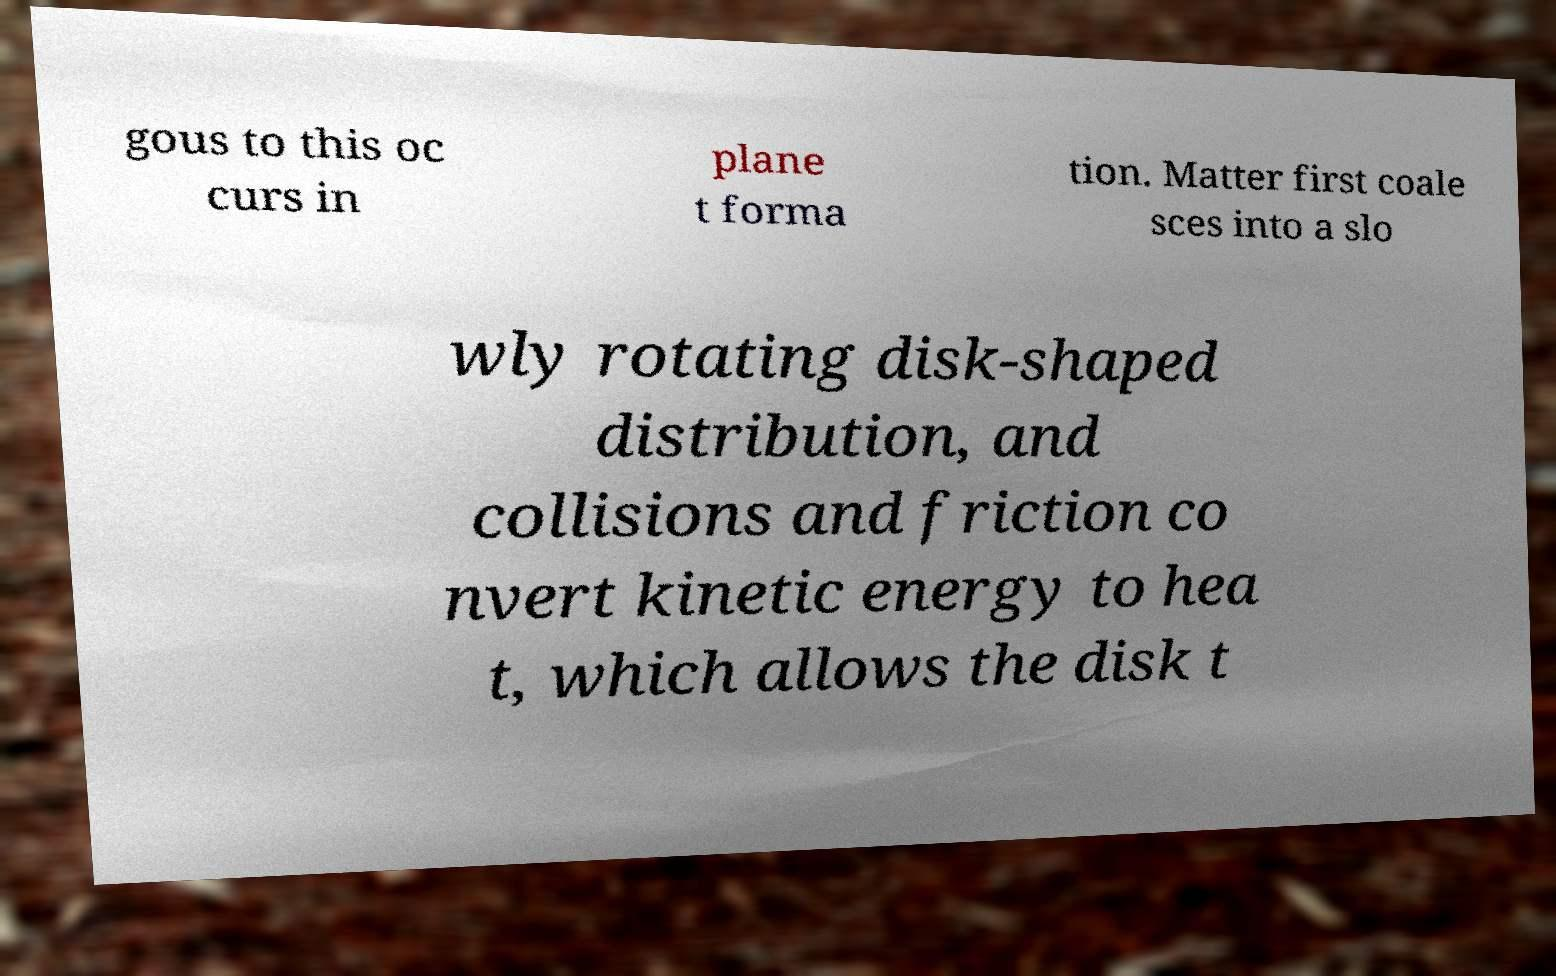I need the written content from this picture converted into text. Can you do that? gous to this oc curs in plane t forma tion. Matter first coale sces into a slo wly rotating disk-shaped distribution, and collisions and friction co nvert kinetic energy to hea t, which allows the disk t 